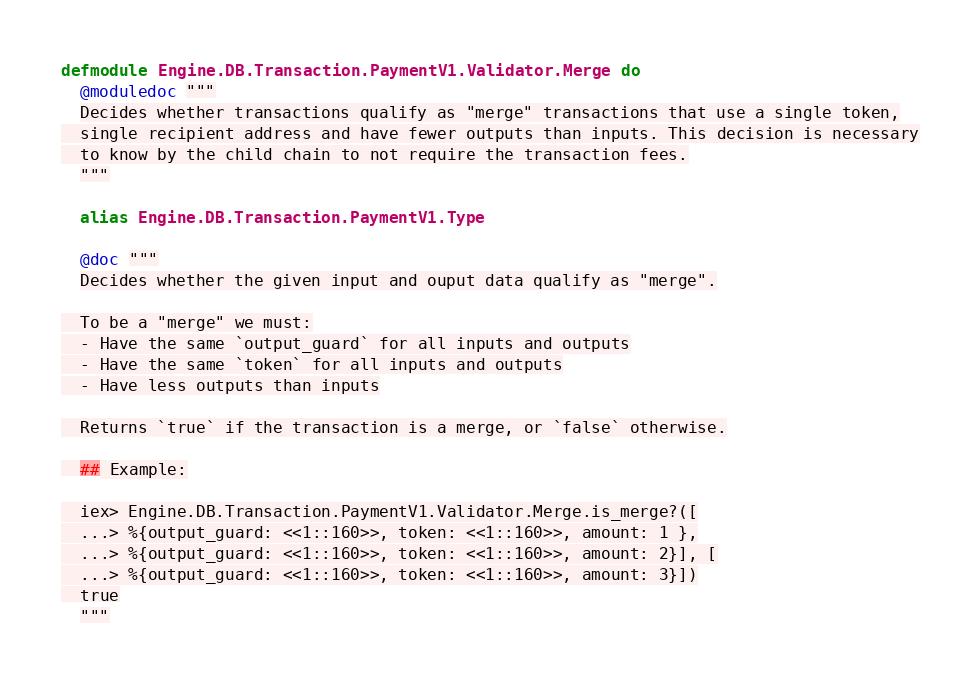Convert code to text. <code><loc_0><loc_0><loc_500><loc_500><_Elixir_>defmodule Engine.DB.Transaction.PaymentV1.Validator.Merge do
  @moduledoc """
  Decides whether transactions qualify as "merge" transactions that use a single token,
  single recipient address and have fewer outputs than inputs. This decision is necessary
  to know by the child chain to not require the transaction fees.
  """

  alias Engine.DB.Transaction.PaymentV1.Type

  @doc """
  Decides whether the given input and ouput data qualify as "merge".

  To be a "merge" we must:
  - Have the same `output_guard` for all inputs and outputs
  - Have the same `token` for all inputs and outputs
  - Have less outputs than inputs

  Returns `true` if the transaction is a merge, or `false` otherwise.

  ## Example:

  iex> Engine.DB.Transaction.PaymentV1.Validator.Merge.is_merge?([
  ...> %{output_guard: <<1::160>>, token: <<1::160>>, amount: 1 },
  ...> %{output_guard: <<1::160>>, token: <<1::160>>, amount: 2}], [
  ...> %{output_guard: <<1::160>>, token: <<1::160>>, amount: 3}])
  true
  """</code> 